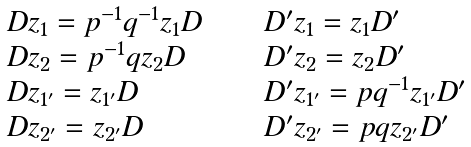<formula> <loc_0><loc_0><loc_500><loc_500>\begin{array} { l c l } D z _ { 1 } = p ^ { - 1 } q ^ { - 1 } z _ { 1 } D & \quad & D ^ { \prime } z _ { 1 } = z _ { 1 } D ^ { \prime } \\ D z _ { 2 } = p ^ { - 1 } q z _ { 2 } D & \quad & D ^ { \prime } z _ { 2 } = z _ { 2 } D ^ { \prime } \\ D z _ { 1 ^ { \prime } } = z _ { 1 ^ { \prime } } D & \quad & D ^ { \prime } z _ { 1 ^ { \prime } } = p q ^ { - 1 } z _ { 1 ^ { \prime } } D ^ { \prime } \\ D z _ { 2 ^ { \prime } } = z _ { 2 ^ { \prime } } D & \quad & D ^ { \prime } z _ { 2 ^ { \prime } } = p q z _ { 2 ^ { \prime } } D ^ { \prime } \end{array}</formula> 